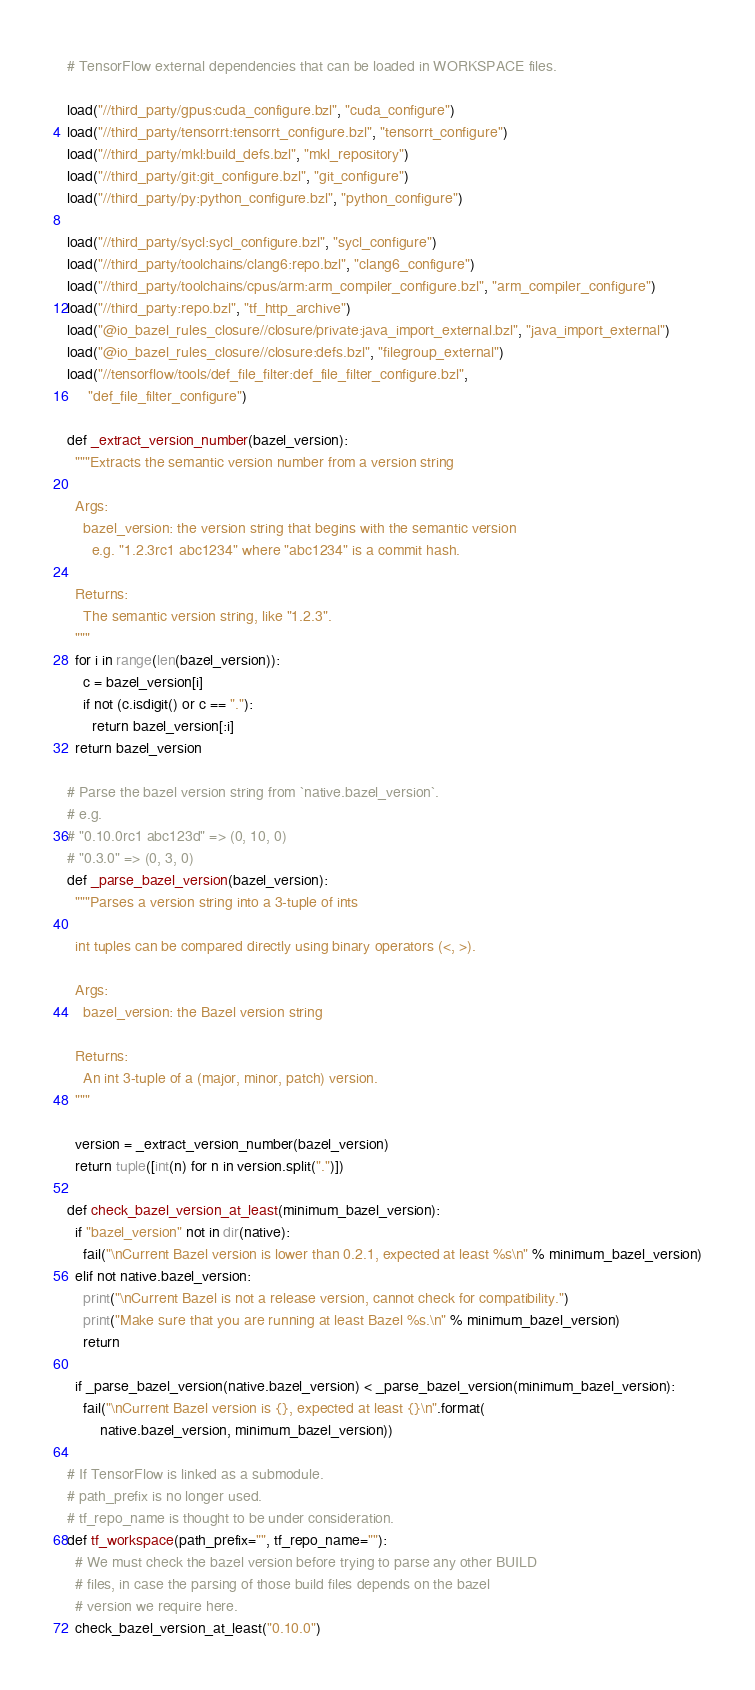<code> <loc_0><loc_0><loc_500><loc_500><_Python_># TensorFlow external dependencies that can be loaded in WORKSPACE files.

load("//third_party/gpus:cuda_configure.bzl", "cuda_configure")
load("//third_party/tensorrt:tensorrt_configure.bzl", "tensorrt_configure")
load("//third_party/mkl:build_defs.bzl", "mkl_repository")
load("//third_party/git:git_configure.bzl", "git_configure")
load("//third_party/py:python_configure.bzl", "python_configure")

load("//third_party/sycl:sycl_configure.bzl", "sycl_configure")
load("//third_party/toolchains/clang6:repo.bzl", "clang6_configure")
load("//third_party/toolchains/cpus/arm:arm_compiler_configure.bzl", "arm_compiler_configure")
load("//third_party:repo.bzl", "tf_http_archive")
load("@io_bazel_rules_closure//closure/private:java_import_external.bzl", "java_import_external")
load("@io_bazel_rules_closure//closure:defs.bzl", "filegroup_external")
load("//tensorflow/tools/def_file_filter:def_file_filter_configure.bzl",
     "def_file_filter_configure")

def _extract_version_number(bazel_version):
  """Extracts the semantic version number from a version string

  Args:
    bazel_version: the version string that begins with the semantic version
      e.g. "1.2.3rc1 abc1234" where "abc1234" is a commit hash.

  Returns:
    The semantic version string, like "1.2.3".
  """
  for i in range(len(bazel_version)):
    c = bazel_version[i]
    if not (c.isdigit() or c == "."):
      return bazel_version[:i]
  return bazel_version

# Parse the bazel version string from `native.bazel_version`.
# e.g.
# "0.10.0rc1 abc123d" => (0, 10, 0)
# "0.3.0" => (0, 3, 0)
def _parse_bazel_version(bazel_version):
  """Parses a version string into a 3-tuple of ints

  int tuples can be compared directly using binary operators (<, >).

  Args:
    bazel_version: the Bazel version string

  Returns:
    An int 3-tuple of a (major, minor, patch) version.
  """

  version = _extract_version_number(bazel_version)
  return tuple([int(n) for n in version.split(".")])

def check_bazel_version_at_least(minimum_bazel_version):
  if "bazel_version" not in dir(native):
    fail("\nCurrent Bazel version is lower than 0.2.1, expected at least %s\n" % minimum_bazel_version)
  elif not native.bazel_version:
    print("\nCurrent Bazel is not a release version, cannot check for compatibility.")
    print("Make sure that you are running at least Bazel %s.\n" % minimum_bazel_version)
    return

  if _parse_bazel_version(native.bazel_version) < _parse_bazel_version(minimum_bazel_version):
    fail("\nCurrent Bazel version is {}, expected at least {}\n".format(
        native.bazel_version, minimum_bazel_version))

# If TensorFlow is linked as a submodule.
# path_prefix is no longer used.
# tf_repo_name is thought to be under consideration.
def tf_workspace(path_prefix="", tf_repo_name=""):
  # We must check the bazel version before trying to parse any other BUILD
  # files, in case the parsing of those build files depends on the bazel
  # version we require here.
  check_bazel_version_at_least("0.10.0")</code> 